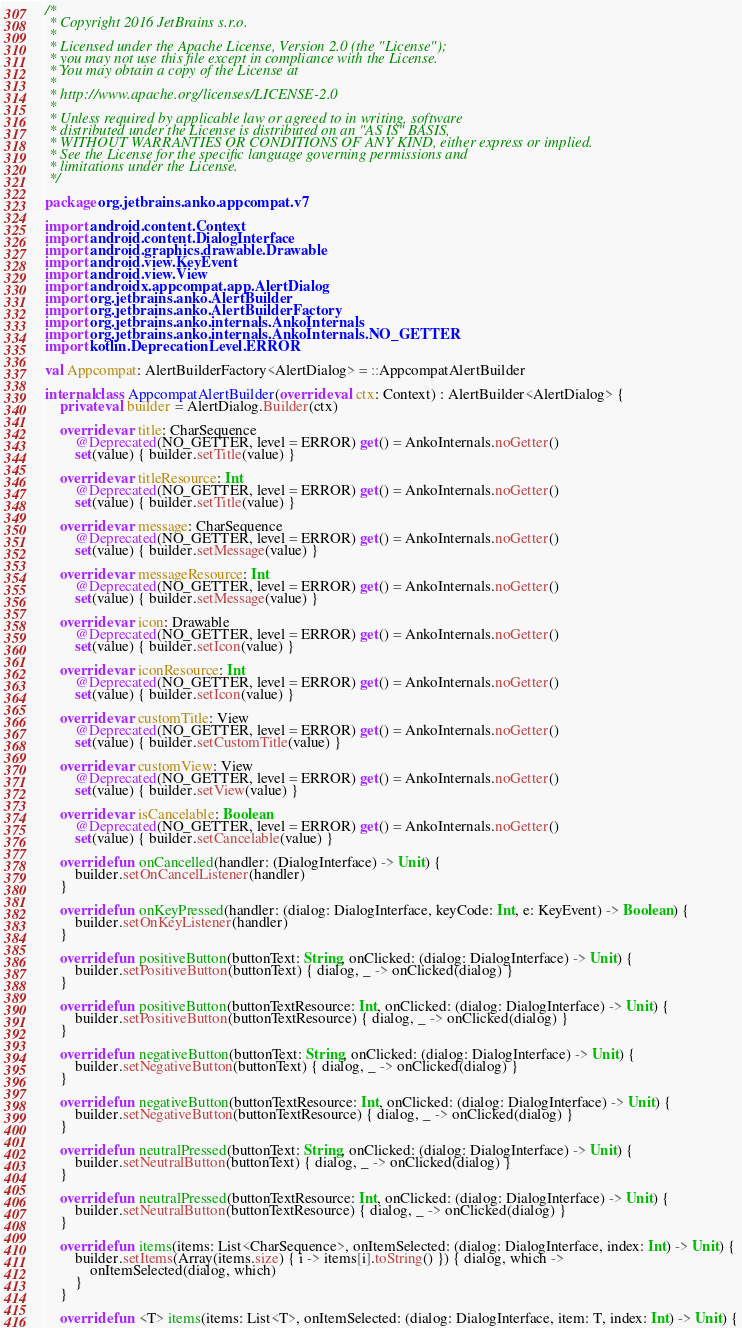Convert code to text. <code><loc_0><loc_0><loc_500><loc_500><_Kotlin_>/*
 * Copyright 2016 JetBrains s.r.o.
 *
 * Licensed under the Apache License, Version 2.0 (the "License");
 * you may not use this file except in compliance with the License.
 * You may obtain a copy of the License at
 *
 * http://www.apache.org/licenses/LICENSE-2.0
 *
 * Unless required by applicable law or agreed to in writing, software
 * distributed under the License is distributed on an "AS IS" BASIS,
 * WITHOUT WARRANTIES OR CONDITIONS OF ANY KIND, either express or implied.
 * See the License for the specific language governing permissions and
 * limitations under the License.
 */

package org.jetbrains.anko.appcompat.v7

import android.content.Context
import android.content.DialogInterface
import android.graphics.drawable.Drawable
import android.view.KeyEvent
import android.view.View
import androidx.appcompat.app.AlertDialog
import org.jetbrains.anko.AlertBuilder
import org.jetbrains.anko.AlertBuilderFactory
import org.jetbrains.anko.internals.AnkoInternals
import org.jetbrains.anko.internals.AnkoInternals.NO_GETTER
import kotlin.DeprecationLevel.ERROR

val Appcompat: AlertBuilderFactory<AlertDialog> = ::AppcompatAlertBuilder

internal class AppcompatAlertBuilder(override val ctx: Context) : AlertBuilder<AlertDialog> {
    private val builder = AlertDialog.Builder(ctx)

    override var title: CharSequence
        @Deprecated(NO_GETTER, level = ERROR) get() = AnkoInternals.noGetter()
        set(value) { builder.setTitle(value) }

    override var titleResource: Int
        @Deprecated(NO_GETTER, level = ERROR) get() = AnkoInternals.noGetter()
        set(value) { builder.setTitle(value) }

    override var message: CharSequence
        @Deprecated(NO_GETTER, level = ERROR) get() = AnkoInternals.noGetter()
        set(value) { builder.setMessage(value) }

    override var messageResource: Int
        @Deprecated(NO_GETTER, level = ERROR) get() = AnkoInternals.noGetter()
        set(value) { builder.setMessage(value) }

    override var icon: Drawable
        @Deprecated(NO_GETTER, level = ERROR) get() = AnkoInternals.noGetter()
        set(value) { builder.setIcon(value) }

    override var iconResource: Int
        @Deprecated(NO_GETTER, level = ERROR) get() = AnkoInternals.noGetter()
        set(value) { builder.setIcon(value) }

    override var customTitle: View
        @Deprecated(NO_GETTER, level = ERROR) get() = AnkoInternals.noGetter()
        set(value) { builder.setCustomTitle(value) }

    override var customView: View
        @Deprecated(NO_GETTER, level = ERROR) get() = AnkoInternals.noGetter()
        set(value) { builder.setView(value) }

    override var isCancelable: Boolean
        @Deprecated(NO_GETTER, level = ERROR) get() = AnkoInternals.noGetter()
        set(value) { builder.setCancelable(value) }

    override fun onCancelled(handler: (DialogInterface) -> Unit) {
        builder.setOnCancelListener(handler)
    }

    override fun onKeyPressed(handler: (dialog: DialogInterface, keyCode: Int, e: KeyEvent) -> Boolean) {
        builder.setOnKeyListener(handler)
    }

    override fun positiveButton(buttonText: String, onClicked: (dialog: DialogInterface) -> Unit) {
        builder.setPositiveButton(buttonText) { dialog, _ -> onClicked(dialog) }
    }

    override fun positiveButton(buttonTextResource: Int, onClicked: (dialog: DialogInterface) -> Unit) {
        builder.setPositiveButton(buttonTextResource) { dialog, _ -> onClicked(dialog) }
    }

    override fun negativeButton(buttonText: String, onClicked: (dialog: DialogInterface) -> Unit) {
        builder.setNegativeButton(buttonText) { dialog, _ -> onClicked(dialog) }
    }

    override fun negativeButton(buttonTextResource: Int, onClicked: (dialog: DialogInterface) -> Unit) {
        builder.setNegativeButton(buttonTextResource) { dialog, _ -> onClicked(dialog) }
    }

    override fun neutralPressed(buttonText: String, onClicked: (dialog: DialogInterface) -> Unit) {
        builder.setNeutralButton(buttonText) { dialog, _ -> onClicked(dialog) }
    }

    override fun neutralPressed(buttonTextResource: Int, onClicked: (dialog: DialogInterface) -> Unit) {
        builder.setNeutralButton(buttonTextResource) { dialog, _ -> onClicked(dialog) }
    }

    override fun items(items: List<CharSequence>, onItemSelected: (dialog: DialogInterface, index: Int) -> Unit) {
        builder.setItems(Array(items.size) { i -> items[i].toString() }) { dialog, which ->
            onItemSelected(dialog, which)
        }
    }

    override fun <T> items(items: List<T>, onItemSelected: (dialog: DialogInterface, item: T, index: Int) -> Unit) {</code> 